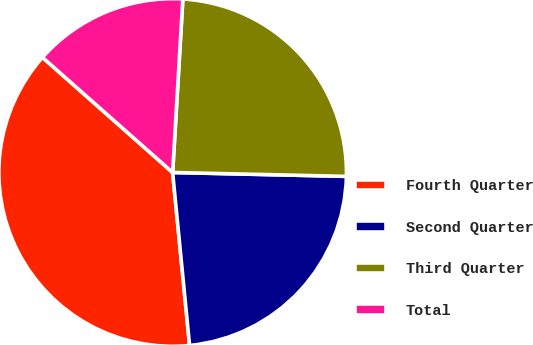<chart> <loc_0><loc_0><loc_500><loc_500><pie_chart><fcel>Fourth Quarter<fcel>Second Quarter<fcel>Third Quarter<fcel>Total<nl><fcel>38.08%<fcel>23.09%<fcel>24.42%<fcel>14.41%<nl></chart> 